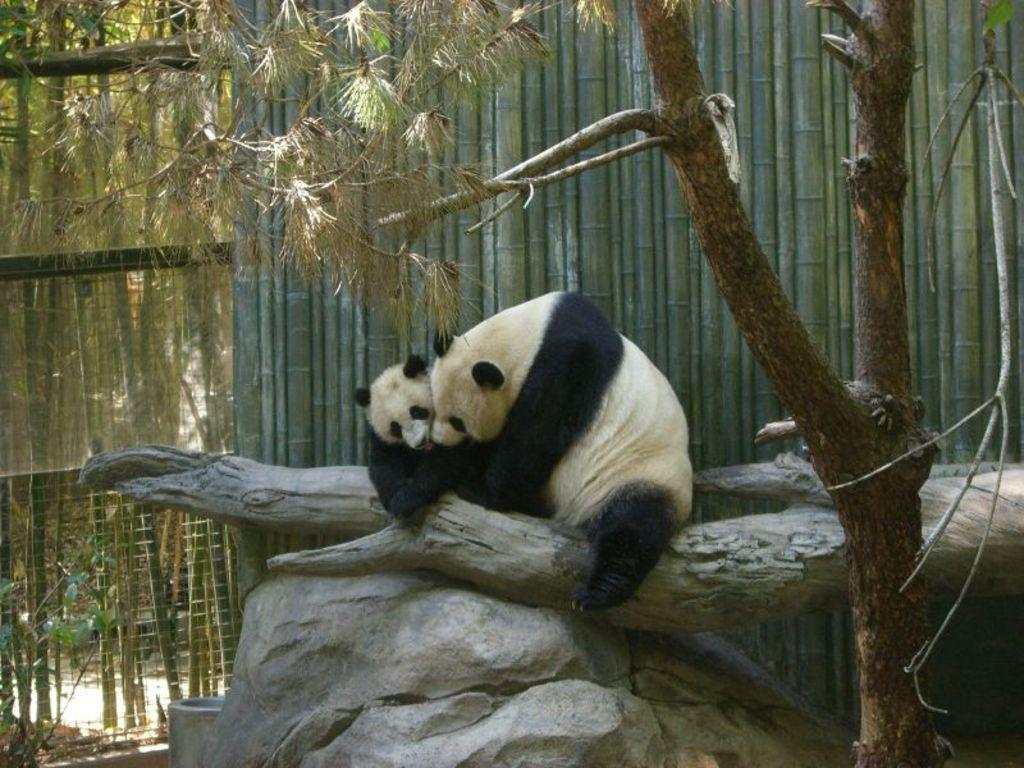How many animals are present in the image? There are two animals in the image. What colors are the animals? The animals are in cream and black color. What can be seen in the background of the image? There are bamboo sticks and a railing visible in the background of the image. What is the color of the trees in the background? The trees in the background are green. Can you tell me how many visitors are present in the image? There is no mention of visitors in the image; it features two animals. What type of lipstick is the kitty wearing in the image? There is no kitty or lipstick present in the image. 